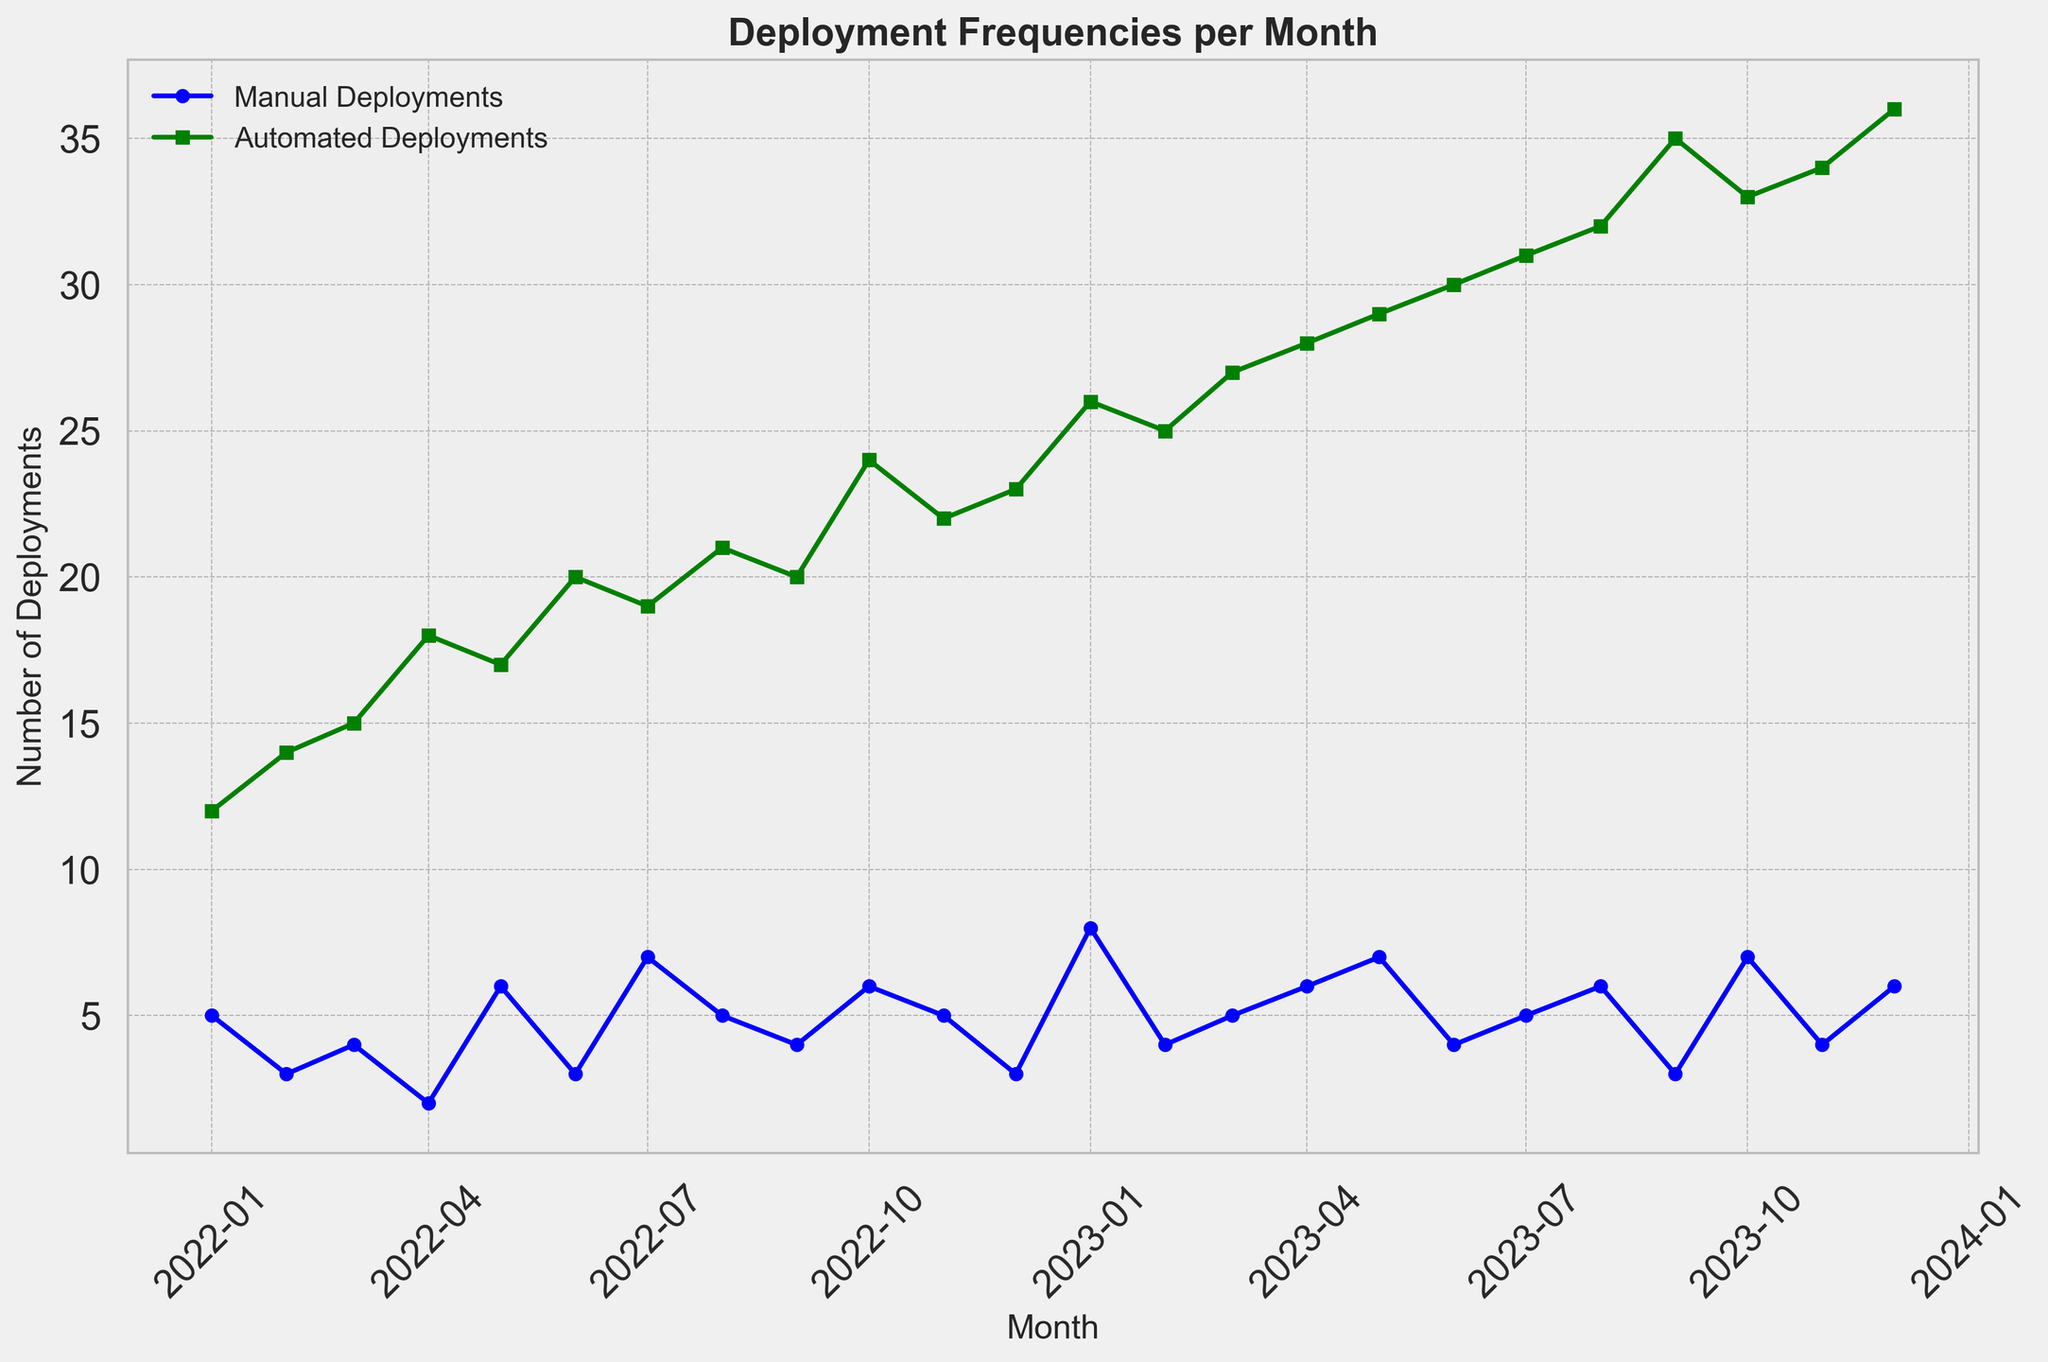What is the month with the highest number of automated deployments? To find this, look at the peak of the green line (Automated Deployments). It's highest in December 2023.
Answer: December 2023 How many more automated deployments were there than manual deployments in January 2023? In January 2023, there were 8 manual and 26 automated deployments. Subtract the manual from the automated: 26 - 8 = 18.
Answer: 18 Which type of deployment increased more steadily over the time period? By examining the slopes of the lines, the green line representing Automated Deployments shows a more consistent, upward trend compared to the blue line of Manual Deployments.
Answer: Automated Deployments What is the difference between the highest and lowest numbers of manual deployments? The highest number of manual deployments is 8 (January 2023), and the lowest is 2 (April 2022). So, 8 - 2 = 6.
Answer: 6 During which months did both manual and automated deployments see a decrease compared to the previous month? Comparing each adjacent month, both deployment types decreased between August and September 2023, and October and November 2023.
Answer: September 2023, November 2023 How does the frequency of automated deployments in the first half of 2023 compare to the second half? Sum the deployments from January to June (103) and compare to July to December (174). The second half of 2023 has significantly more automated deployments.
Answer: The second half has more What is the average number of manual deployments per month in 2022? Sum the manual deployments for 2022 (5+3+4+2+6+3+7+5+4+6+5+3 = 53) and divide by 12 months. 53 / 12 ≈ 4.42.
Answer: Approximately 4.42 In which month was the gap between manual and automated deployments the smallest? Check all the months for differences and find the smallest. The smallest gap is in June 2023 (26 automated and 8 manual, difference of 18).
Answer: January 2023 What colors are used to represent the deployment methods, and which one represents Automated Deployments? The green line represents Automated Deployments and the blue line represents Manual Deployments.
Answer: Green for Automated Deployments, Blue for Manual Deployments 